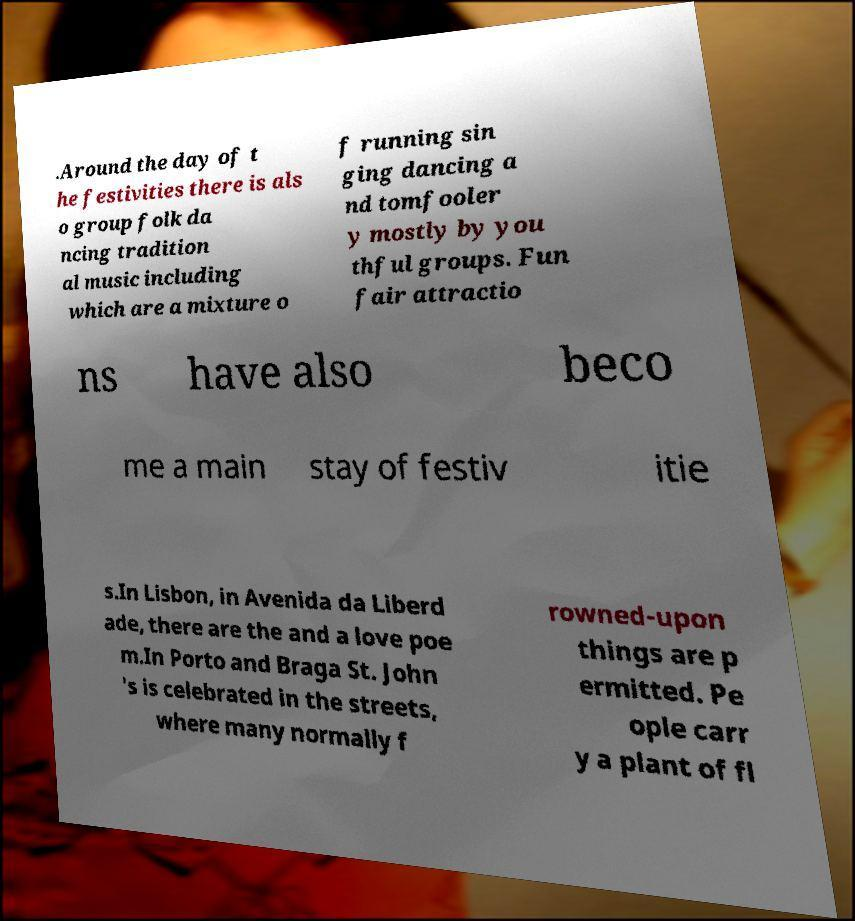There's text embedded in this image that I need extracted. Can you transcribe it verbatim? .Around the day of t he festivities there is als o group folk da ncing tradition al music including which are a mixture o f running sin ging dancing a nd tomfooler y mostly by you thful groups. Fun fair attractio ns have also beco me a main stay of festiv itie s.In Lisbon, in Avenida da Liberd ade, there are the and a love poe m.In Porto and Braga St. John 's is celebrated in the streets, where many normally f rowned-upon things are p ermitted. Pe ople carr y a plant of fl 